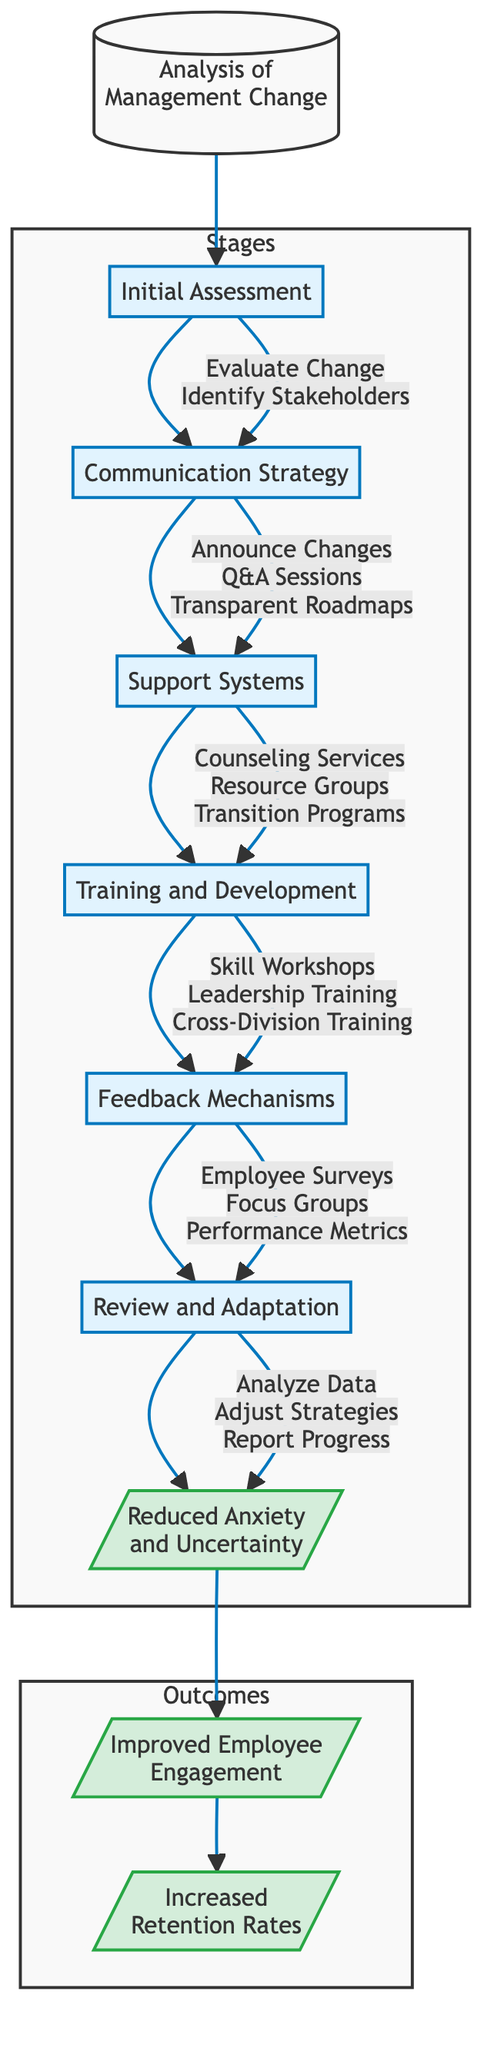What is the starting point of the pathway? The diagram indicates that the pathway begins with "Analysis of Management Change." This is the initial action node that sets the direction for the subsequent stages.
Answer: Analysis of Management Change How many stages are there in the diagram? Upon reviewing the nodes within the categorized 'Stages' section, there are six distinct stages listed: Initial Assessment, Communication Strategy, Support Systems, Training and Development, Feedback Mechanisms, and Review and Adaptation.
Answer: 6 What is the outcome after the "Review and Adaptation" stage? The diagram indicates that following the "Review and Adaptation" stage, the next outcome achieved is the "Reduced Anxiety and Uncertainty Among Employees." This links the actions taken to direct outcomes of the pathway.
Answer: Reduced Anxiety and Uncertainty Among Employees What actions are taken during the "Support Systems" stage? The "Support Systems" stage has three specific actions indicated in the diagram: "Introduce Counseling Services," "Establish Employee Resource Groups," and "Develop Career Transition Programs." Each contributes to employee support during management changes.
Answer: Introduce Counseling Services, Establish Employee Resource Groups, Develop Career Transition Programs Which stage directly follows the "Communication Strategy"? Following the "Communication Strategy" stage, the next stage in the pathway is "Support Systems." This indicates that after communication efforts, the organization focuses on providing support structures for employees.
Answer: Support Systems What is the long-term outcome of the pathway? The diagram shows that the ultimate long-term outcome is "Increased Retention Rates," signifying the desired effect of the entire management change pathway aimed at sustaining employment.
Answer: Increased Retention Rates How are employee sentiments monitored according to the diagram? According to the diagram, employee sentiments are monitored through "Conduct Regular Employee Surveys," "Organize Focus Groups," and "Monitor Performance Metrics," all of which are part of the Feedback Mechanisms stage.
Answer: Conduct Regular Employee Surveys, Organize Focus Groups, Monitor Performance Metrics What is the relationship between the "Initial Assessment" and the "Communication Strategy"? The relationship between the "Initial Assessment" and the "Communication Strategy" is sequential; the "Initial Assessment" provides necessary evaluations that inform and lead into the next action of "Communication Strategy."
Answer: Sequential relationship Which outcome is expected to be achieved in the medium term? Based on the diagram, the expected outcome in the medium term is "Improved Employee Engagement," which follows the short-term outcome and represents an intermediate step towards long-term gains.
Answer: Improved Employee Engagement 